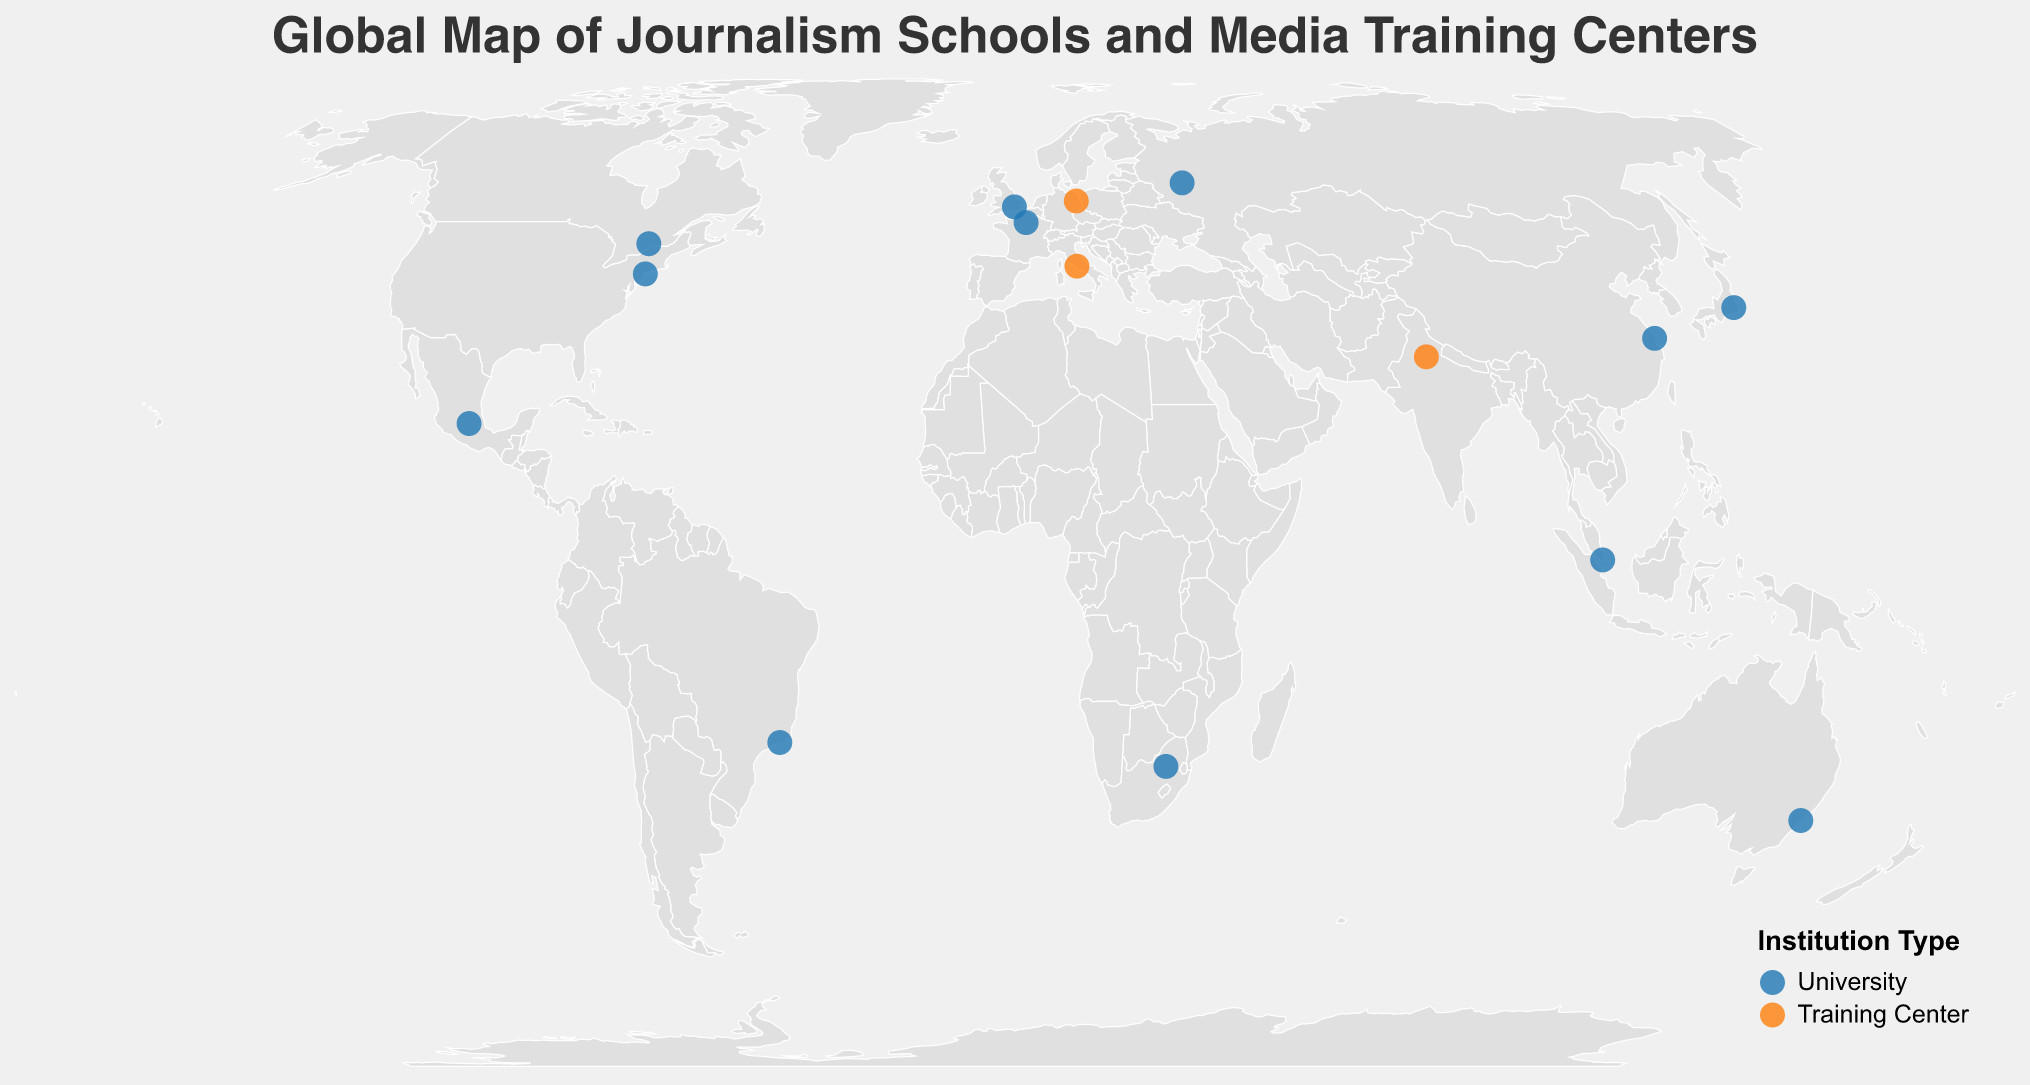What is the title of the map? The title is displayed prominently at the top of the figure and reads "Global Map of Journalism Schools and Media Training Centers".
Answer: Global Map of Journalism Schools and Media Training Centers What color represents universities on the map? The legend at the bottom right of the map indicates that universities are represented in blue.
Answer: Blue How many journalism institutions are located in Africa? By visually inspecting the map, there is only one dot located in Africa, representing Wits Journalism in South Africa.
Answer: 1 Which institution focuses on Data Journalism? By referring to the tooltip information available when hovering over the dots, Carleton University School of Journalism in Canada focuses on Data Journalism.
Answer: Carleton University School of Journalism Are there more universities or training centers shown on the map? By counting the number of blue and orange dots on the map, there are more blue dots (universities) than orange dots (training centers).
Answer: More universities Which countries have training centers represented on the map? By looking at the tooltip or identifying the orange dots, the countries with training centers are Germany, Italy, and India.
Answer: Germany, Italy, and India What is the focus area of the institution located in Japan? By referring to the tooltip for the dot on Japan, Waseda University in Japan focuses on Digital Media.
Answer: Digital Media Which institution is located at approximately 48.8566, 2.3522? By referencing the coordinates on the map, Sciences Po Journalism School in France is located at approximately this latitude and longitude.
Answer: Sciences Po Journalism School Compare the focus of the institutions in the USA and UK. By looking at the tooltip information for institutions in the USA and UK, Columbia Journalism School in the USA focuses on Investigative Journalism, while City University of London in the UK focuses on Broadcast Journalism.
Answer: Investigative Journalism vs. Broadcast Journalism Which institution in South America focuses on Sports Journalism? By referring to the tooltip information on the dots in South America, the Pontifical Catholic University of Rio de Janeiro in Brazil focuses on Sports Journalism.
Answer: Pontifical Catholic University of Rio de Janeiro 